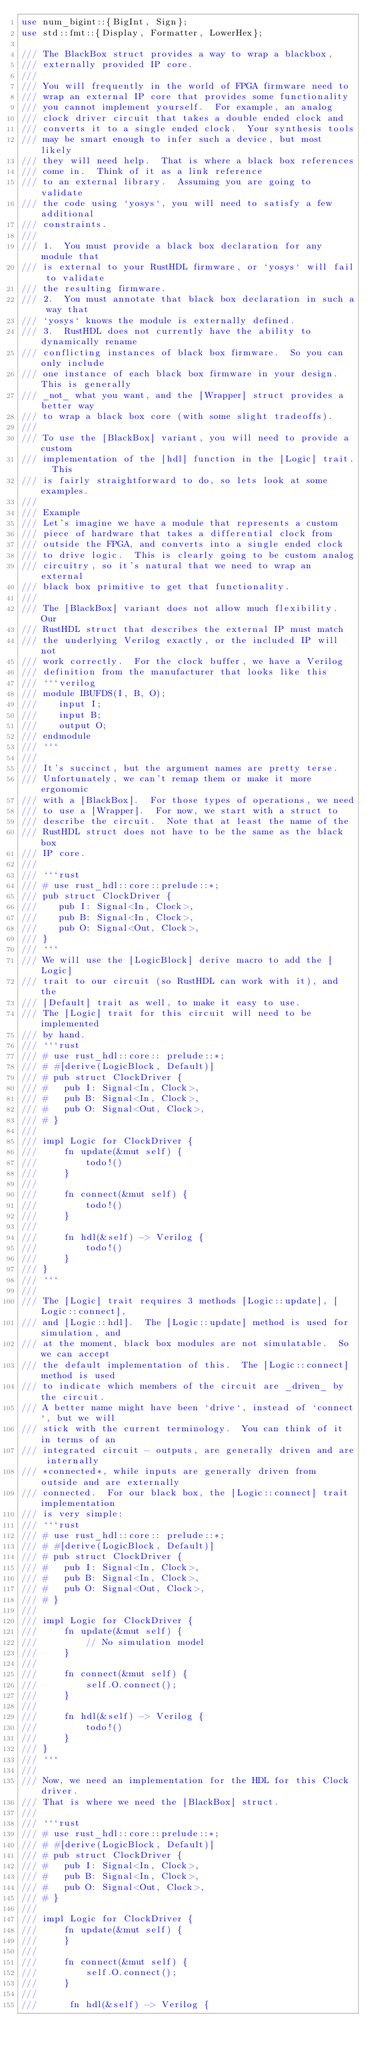Convert code to text. <code><loc_0><loc_0><loc_500><loc_500><_Rust_>use num_bigint::{BigInt, Sign};
use std::fmt::{Display, Formatter, LowerHex};

/// The BlackBox struct provides a way to wrap a blackbox,
/// externally provided IP core.
///
/// You will frequently in the world of FPGA firmware need to
/// wrap an external IP core that provides some functionality
/// you cannot implement yourself.  For example, an analog
/// clock driver circuit that takes a double ended clock and
/// converts it to a single ended clock.  Your synthesis tools
/// may be smart enough to infer such a device, but most likely
/// they will need help.  That is where a black box references
/// come in.  Think of it as a link reference
/// to an external library.  Assuming you are going to validate
/// the code using `yosys`, you will need to satisfy a few additional
/// constraints.
///
/// 1.  You must provide a black box declaration for any module that
/// is external to your RustHDL firmware, or `yosys` will fail to validate
/// the resulting firmware.
/// 2.  You must annotate that black box declaration in such a way that
/// `yosys` knows the module is externally defined.
/// 3.  RustHDL does not currently have the ability to dynamically rename
/// conflicting instances of black box firmware.  So you can only include
/// one instance of each black box firmware in your design.  This is generally
/// _not_ what you want, and the [Wrapper] struct provides a better way
/// to wrap a black box core (with some slight tradeoffs).
///
/// To use the [BlackBox] variant, you will need to provide a custom
/// implementation of the [hdl] function in the [Logic] trait.  This
/// is fairly straightforward to do, so lets look at some examples.
///
/// Example
/// Let's imagine we have a module that represents a custom
/// piece of hardware that takes a differential clock from
/// outside the FPGA, and converts into a single ended clock
/// to drive logic.  This is clearly going to be custom analog
/// circuitry, so it's natural that we need to wrap an external
/// black box primitive to get that functionality.
///
/// The [BlackBox] variant does not allow much flexibility.  Our
/// RustHDL struct that describes the external IP must match
/// the underlying Verilog exactly, or the included IP will not
/// work correctly.  For the clock buffer, we have a Verilog
/// definition from the manufacturer that looks like this
/// ```verilog
/// module IBUFDS(I, B, O);
///    input I;
///    input B;
///    output O;
/// endmodule
/// ```
///
/// It's succinct, but the argument names are pretty terse.
/// Unfortunately, we can't remap them or make it more ergonomic
/// with a [BlackBox].  For those types of operations, we need
/// to use a [Wrapper].  For now, we start with a struct to
/// describe the circuit.  Note that at least the name of the
/// RustHDL struct does not have to be the same as the black box
/// IP core.
///
/// ```rust
/// # use rust_hdl::core::prelude::*;
/// pub struct ClockDriver {
///    pub I: Signal<In, Clock>,
///    pub B: Signal<In, Clock>,
///    pub O: Signal<Out, Clock>,
/// }
/// ```
/// We will use the [LogicBlock] derive macro to add the [Logic]
/// trait to our circuit (so RustHDL can work with it), and the
/// [Default] trait as well, to make it easy to use.
/// The [Logic] trait for this circuit will need to be implemented
/// by hand.
/// ```rust
/// # use rust_hdl::core:: prelude::*;
/// # #[derive(LogicBlock, Default)]
/// # pub struct ClockDriver {
/// #   pub I: Signal<In, Clock>,
/// #   pub B: Signal<In, Clock>,
/// #   pub O: Signal<Out, Clock>,
/// # }
///
/// impl Logic for ClockDriver {
///     fn update(&mut self) {
///         todo!()
///     }
///
///     fn connect(&mut self) {
///         todo!()
///     }
///
///     fn hdl(&self) -> Verilog {
///         todo!()
///     }
/// }
/// ```
///
/// The [Logic] trait requires 3 methods [Logic::update], [Logic::connect],
/// and [Logic::hdl].  The [Logic::update] method is used for simulation, and
/// at the moment, black box modules are not simulatable.  So we can accept
/// the default implementation of this.  The [Logic::connect] method is used
/// to indicate which members of the circuit are _driven_ by the circuit.
/// A better name might have been `drive`, instead of `connect`, but we will
/// stick with the current terminology.  You can think of it in terms of an
/// integrated circuit - outputs, are generally driven and are internally
/// *connected*, while inputs are generally driven from outside and are externally
/// connected.  For our black box, the [Logic::connect] trait implementation
/// is very simple:
/// ```rust
/// # use rust_hdl::core:: prelude::*;
/// # #[derive(LogicBlock, Default)]
/// # pub struct ClockDriver {
/// #   pub I: Signal<In, Clock>,
/// #   pub B: Signal<In, Clock>,
/// #   pub O: Signal<Out, Clock>,
/// # }
///
/// impl Logic for ClockDriver {
///     fn update(&mut self) {
///         // No simulation model
///     }
///
///     fn connect(&mut self) {
///         self.O.connect();
///     }
///
///     fn hdl(&self) -> Verilog {
///         todo!()
///     }
/// }
/// ```
///
/// Now, we need an implementation for the HDL for this Clock driver.
/// That is where we need the [BlackBox] struct.
///
/// ```rust
/// # use rust_hdl::core::prelude::*;
/// # #[derive(LogicBlock, Default)]
/// # pub struct ClockDriver {
/// #   pub I: Signal<In, Clock>,
/// #   pub B: Signal<In, Clock>,
/// #   pub O: Signal<Out, Clock>,
/// # }
///
/// impl Logic for ClockDriver {
///     fn update(&mut self) {
///     }
///
///     fn connect(&mut self) {
///         self.O.connect();
///     }
///
///      fn hdl(&self) -> Verilog {</code> 